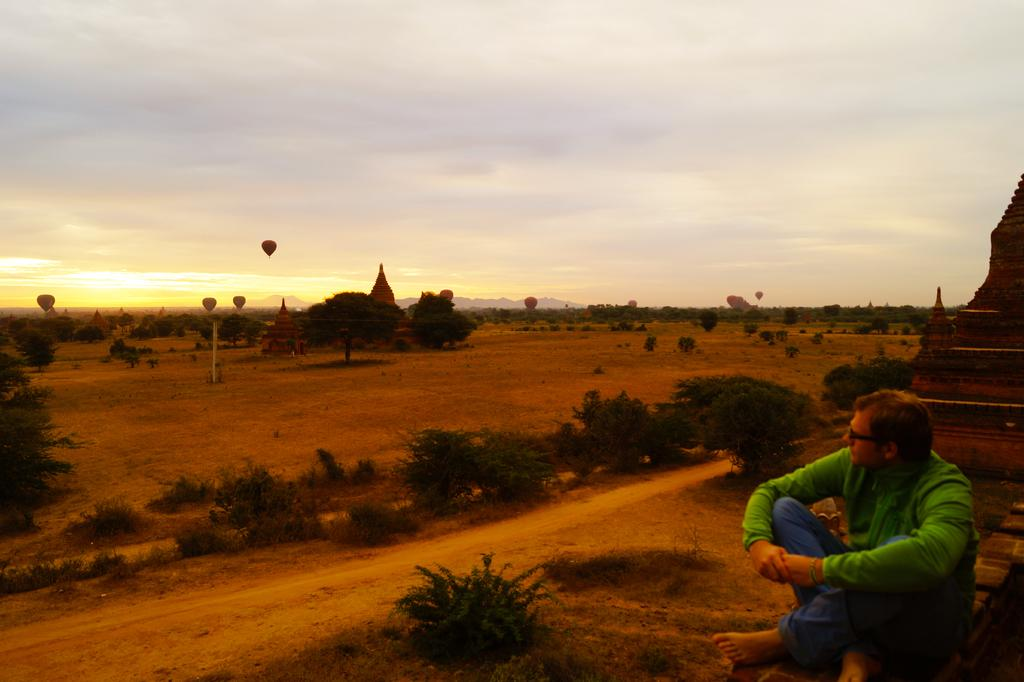What is the man in the image doing? The man is sitting on the ground on the right side of the image. What can be seen in the center of the image? There are bushes and trees in the center of the image. What is visible in the sky in the background of the image? There are hot air balloons visible in the sky in the background of the image. What type of paint is being used by the man in the image? There is no paint or painting activity present in the image. The man is simply sitting on the ground. 